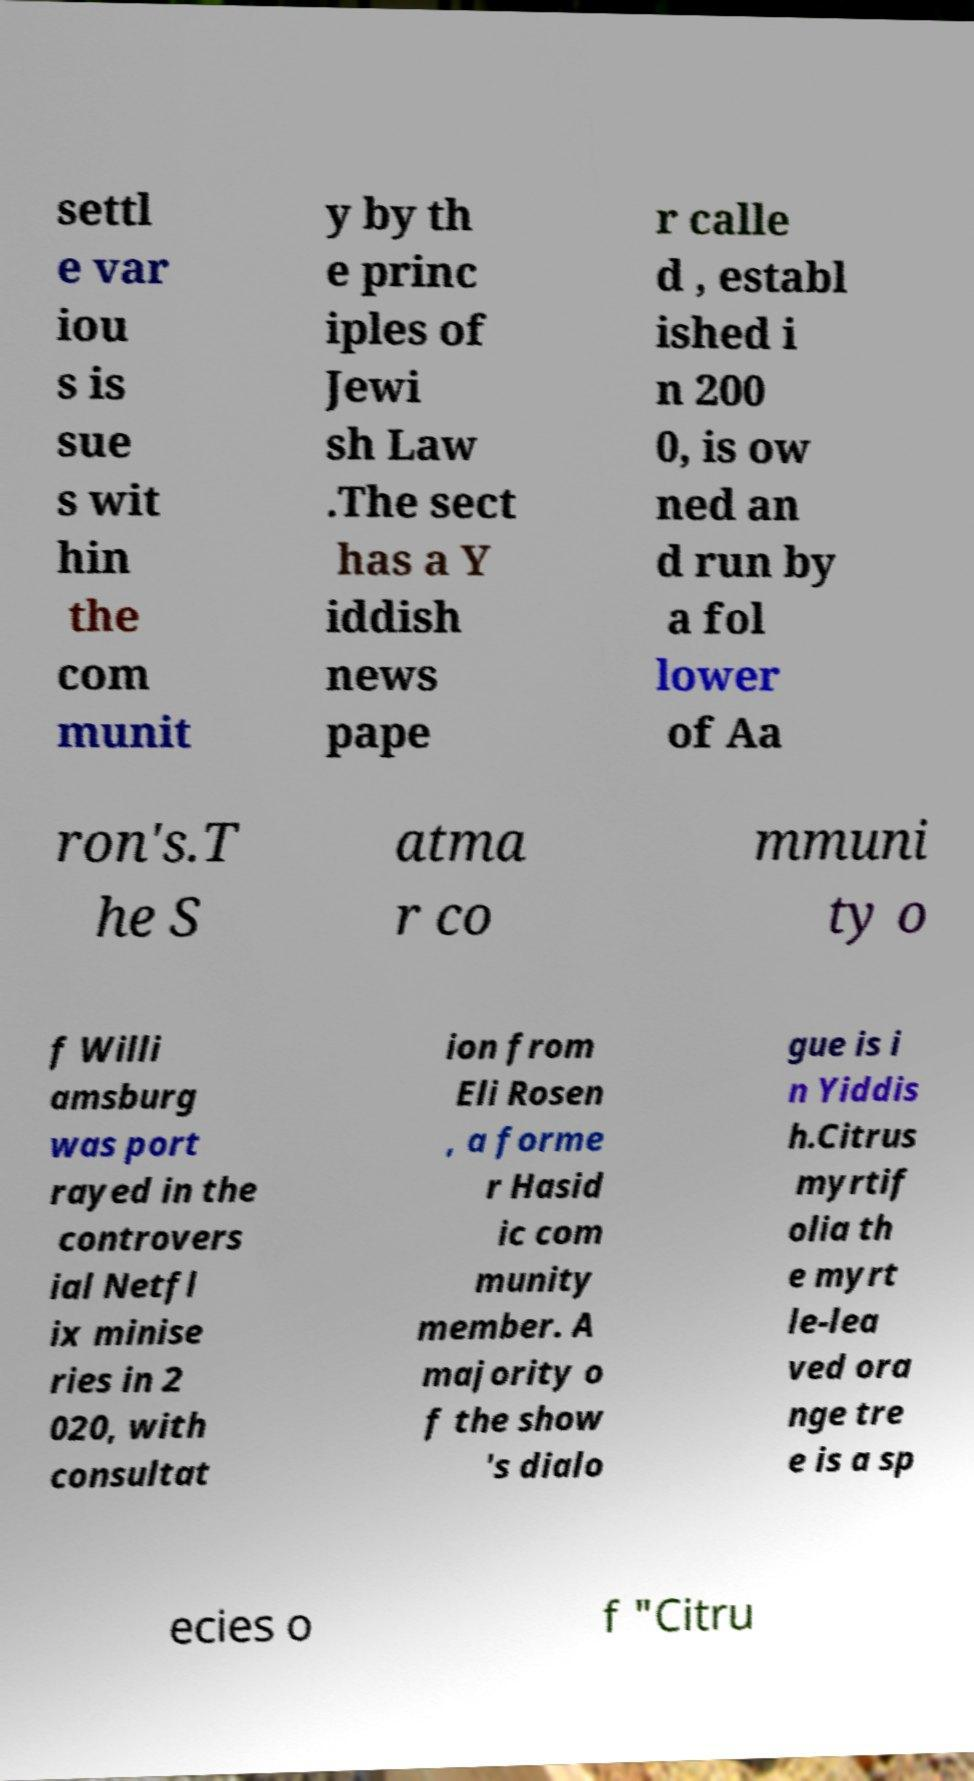Can you read and provide the text displayed in the image?This photo seems to have some interesting text. Can you extract and type it out for me? settl e var iou s is sue s wit hin the com munit y by th e princ iples of Jewi sh Law .The sect has a Y iddish news pape r calle d , establ ished i n 200 0, is ow ned an d run by a fol lower of Aa ron's.T he S atma r co mmuni ty o f Willi amsburg was port rayed in the controvers ial Netfl ix minise ries in 2 020, with consultat ion from Eli Rosen , a forme r Hasid ic com munity member. A majority o f the show 's dialo gue is i n Yiddis h.Citrus myrtif olia th e myrt le-lea ved ora nge tre e is a sp ecies o f "Citru 